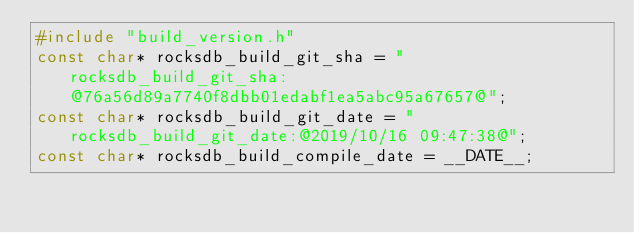<code> <loc_0><loc_0><loc_500><loc_500><_C++_>#include "build_version.h"
const char* rocksdb_build_git_sha = "rocksdb_build_git_sha:@76a56d89a7740f8dbb01edabf1ea5abc95a67657@";
const char* rocksdb_build_git_date = "rocksdb_build_git_date:@2019/10/16 09:47:38@";
const char* rocksdb_build_compile_date = __DATE__;
</code> 